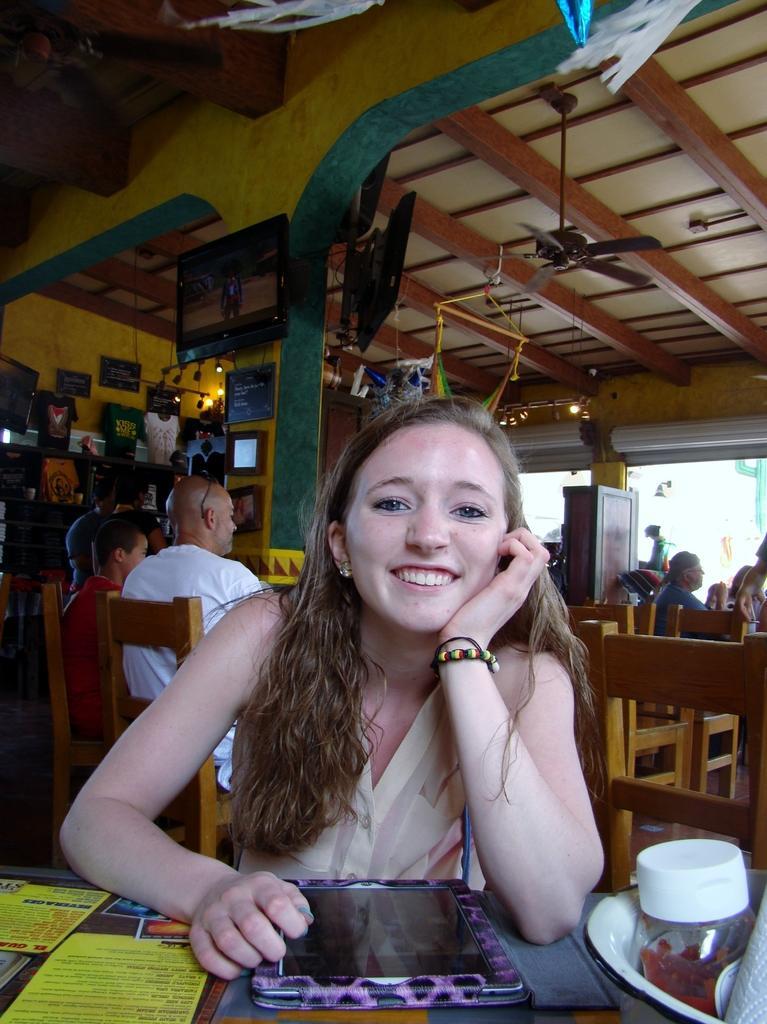In one or two sentences, can you explain what this image depicts? In this picture I can see a woman at the bottom and there is a tab on the table. In the background few persons are sitting on the chairs, at the top there is a fan. On the left side there are televisions. 